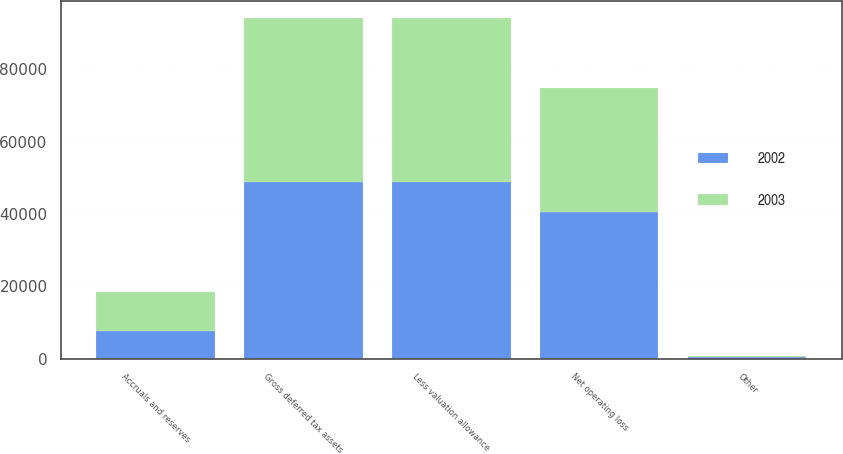<chart> <loc_0><loc_0><loc_500><loc_500><stacked_bar_chart><ecel><fcel>Net operating loss<fcel>Accruals and reserves<fcel>Other<fcel>Gross deferred tax assets<fcel>Less valuation allowance<nl><fcel>2003<fcel>34270<fcel>10880<fcel>80<fcel>45230<fcel>45230<nl><fcel>2002<fcel>40657<fcel>7602<fcel>592<fcel>48851<fcel>48851<nl></chart> 